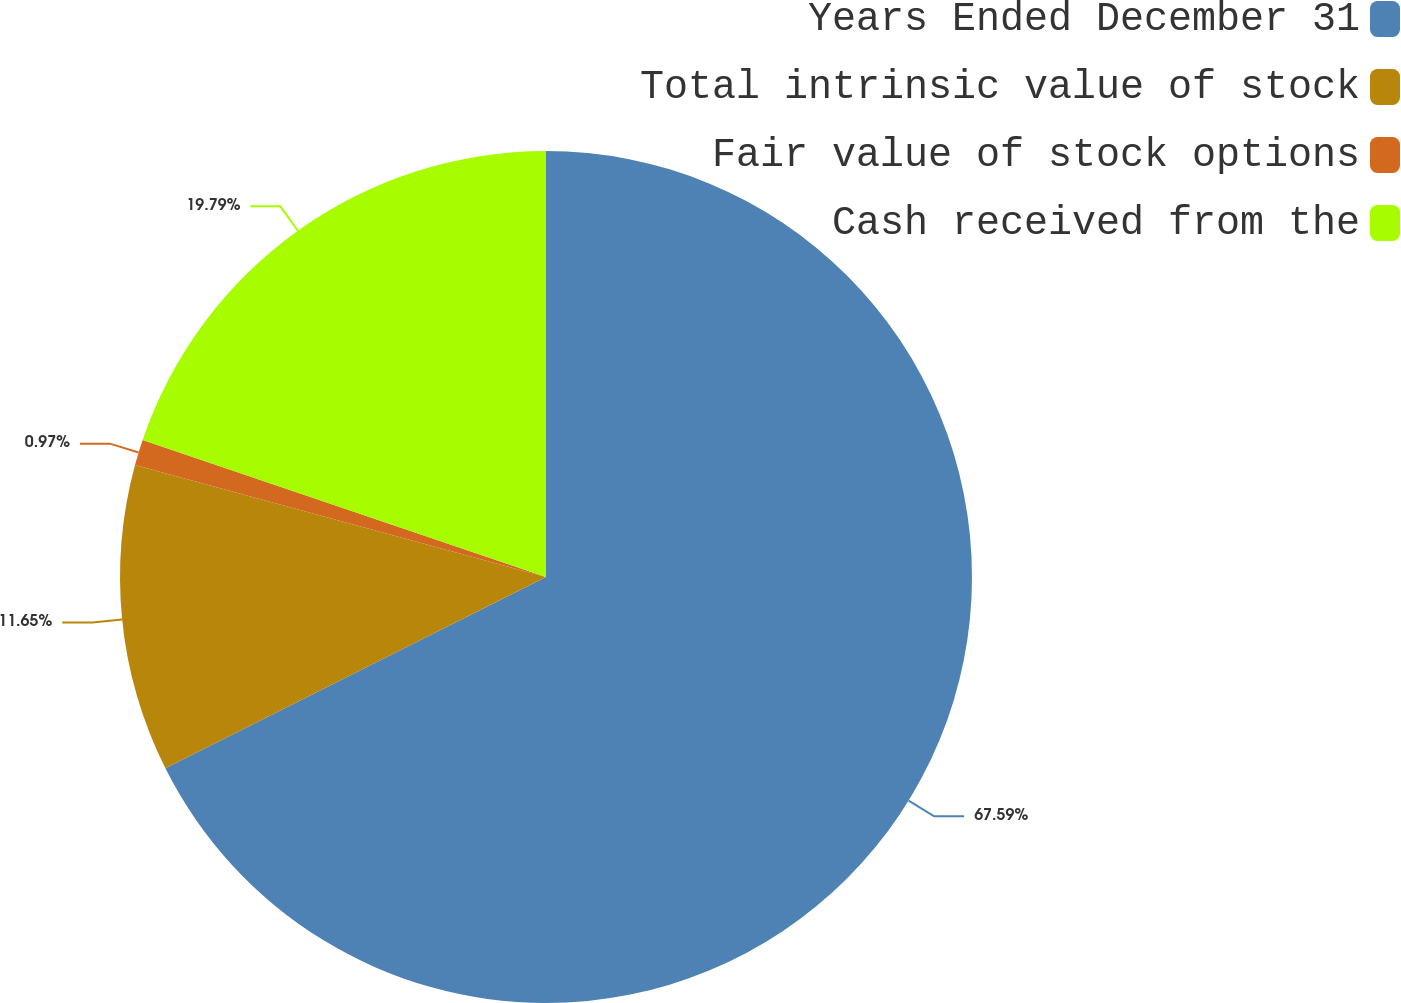<chart> <loc_0><loc_0><loc_500><loc_500><pie_chart><fcel>Years Ended December 31<fcel>Total intrinsic value of stock<fcel>Fair value of stock options<fcel>Cash received from the<nl><fcel>67.58%<fcel>11.65%<fcel>0.97%<fcel>19.79%<nl></chart> 